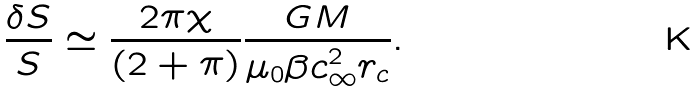<formula> <loc_0><loc_0><loc_500><loc_500>\frac { \delta S } { S } \simeq \frac { 2 \pi \chi } { ( 2 + \pi ) } \frac { G M } { \mu _ { 0 } \beta c _ { \infty } ^ { 2 } r _ { c } } .</formula> 